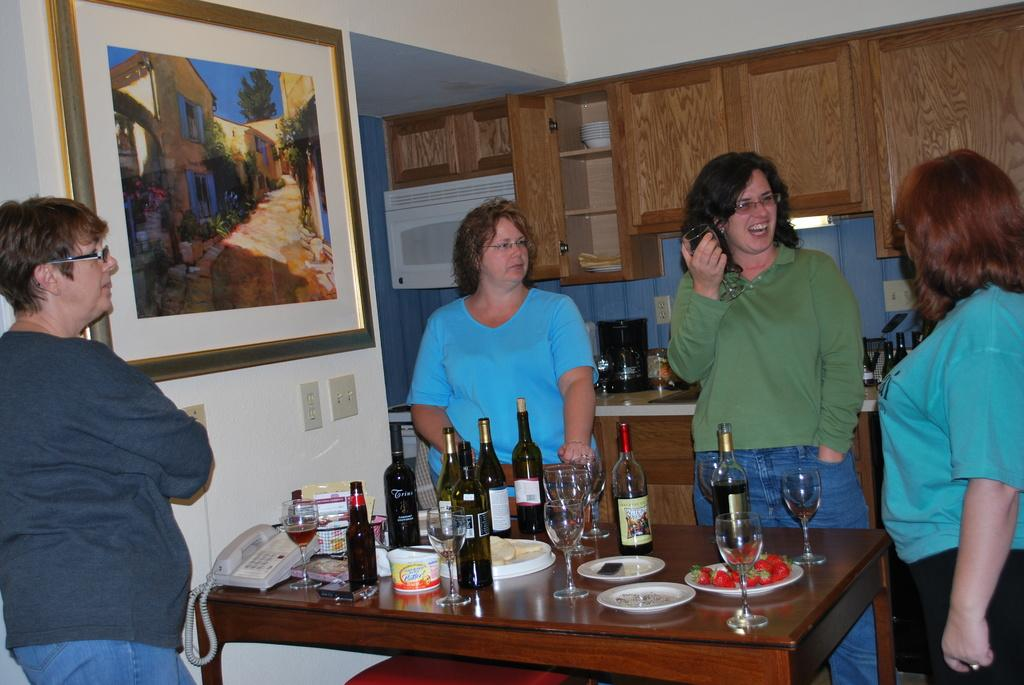How many women are present in the image? There are 4 women in the image. What are the women doing in the image? The women are standing around a table. What objects can be seen on the table? There are wine glasses and plates on the table. What is on the wall in the image? There is a wall painting or photo on the wall. What type of transport can be seen in the image? There is no transport visible in the image. Can you describe the locket that one of the women is wearing in the image? There is no locket mentioned or visible in the image. 